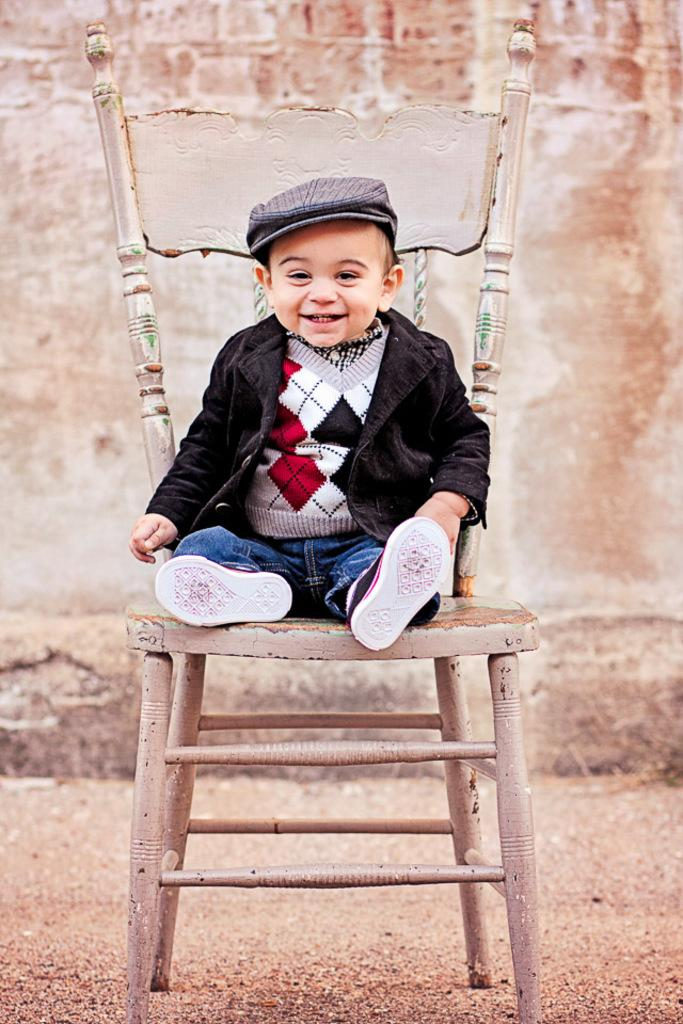What is the main subject of the image? The main subject of the image is a kid. What is the kid doing in the image? The kid is seated on a chair. What expression does the kid have in the image? The kid is smiling. What type of neck can be seen on the cherry in the image? There is no cherry present in the image, so it is not possible to determine what type of neck might be on a cherry. 